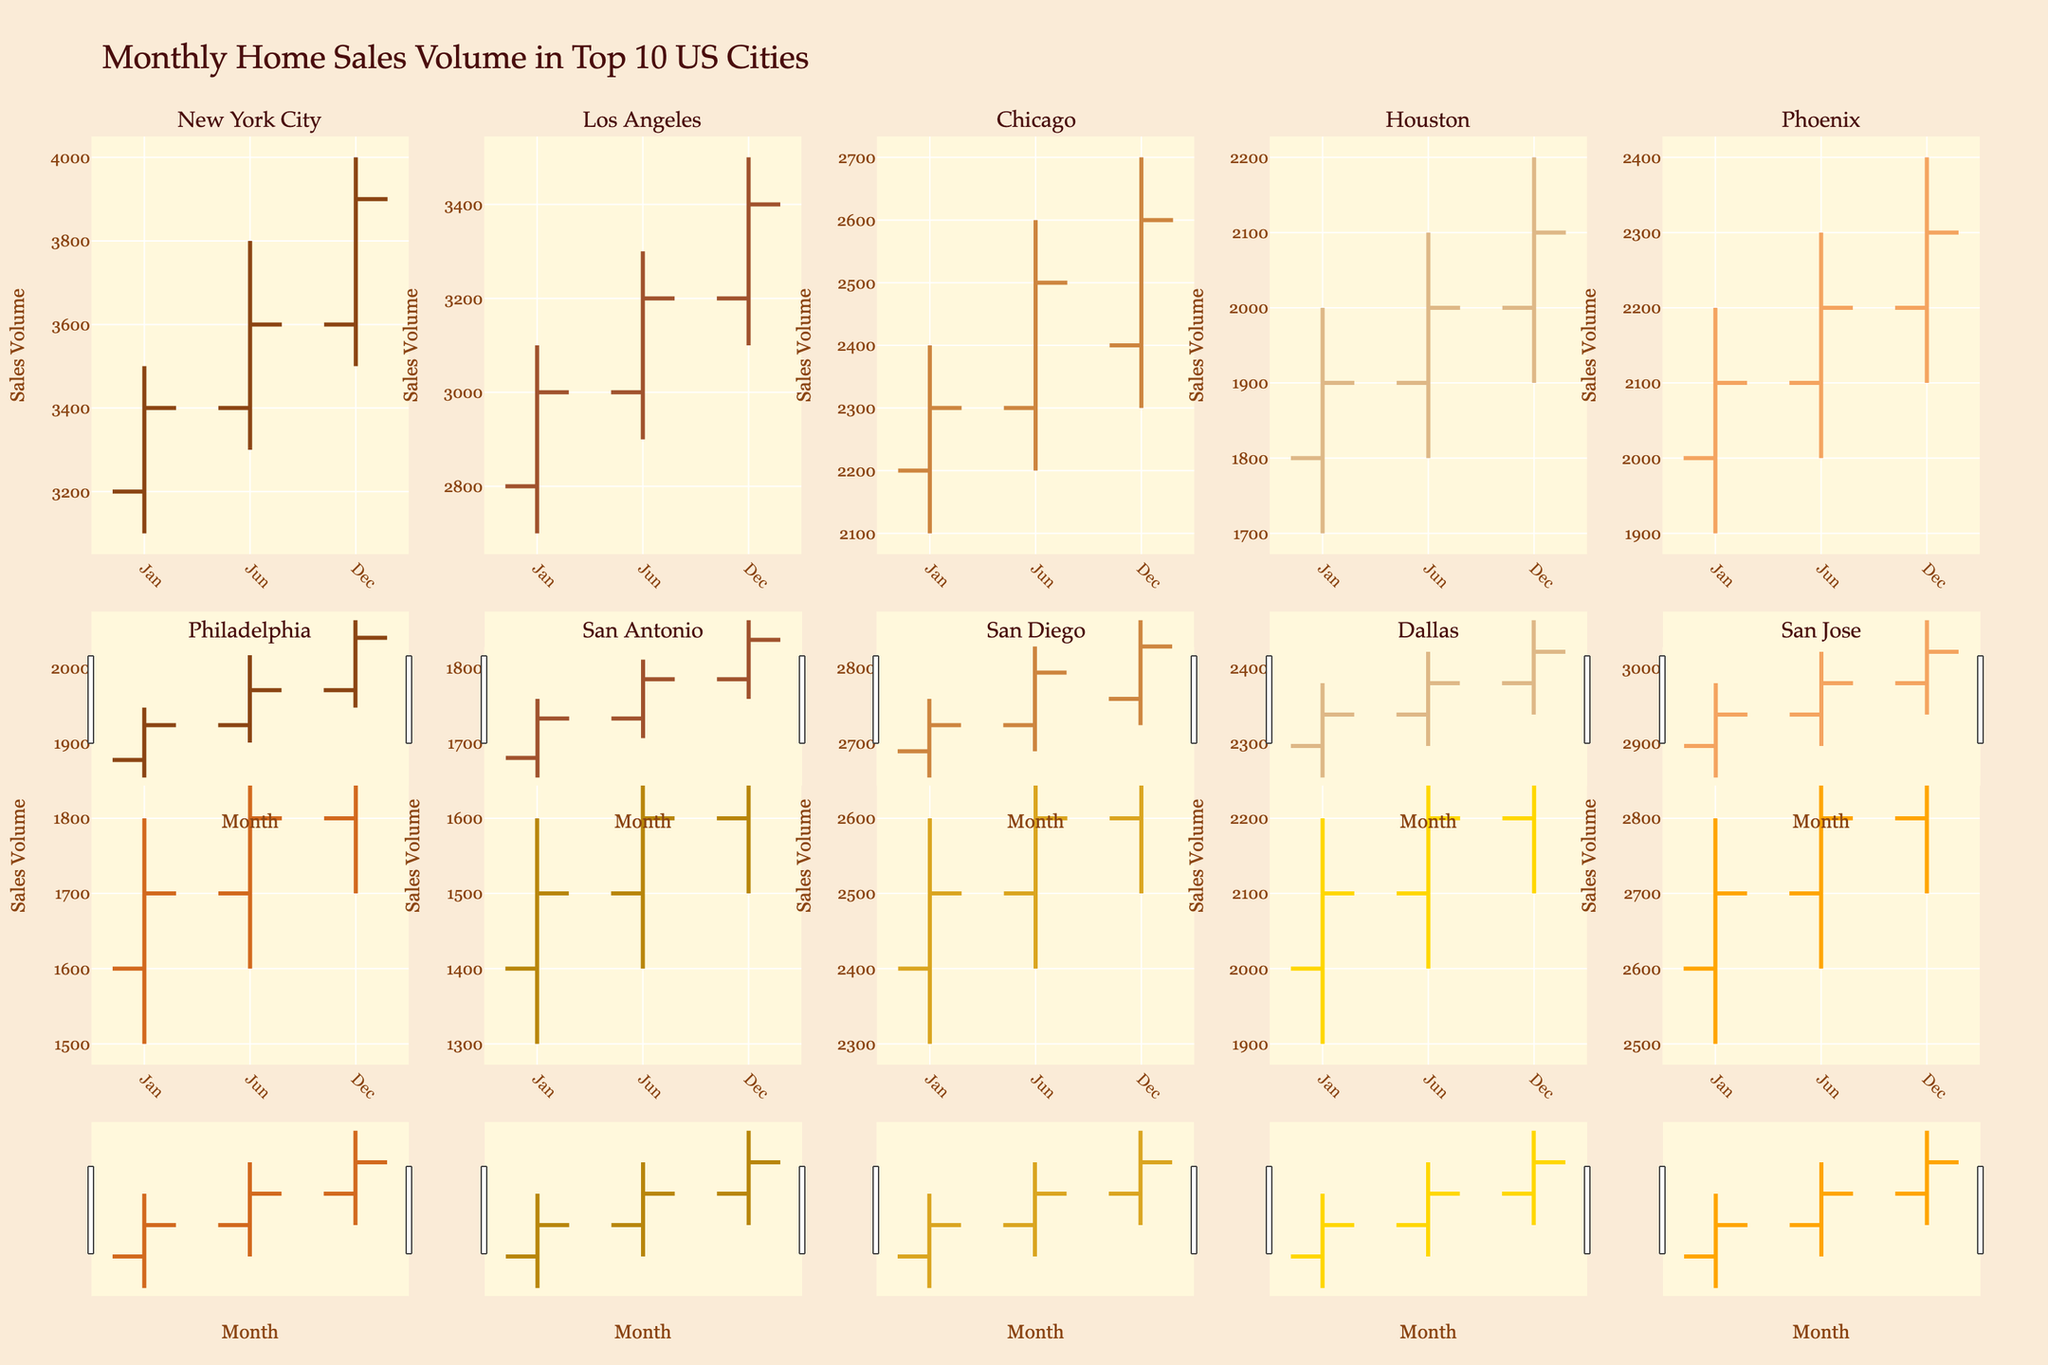What is the main title of the chart? The chart title is located at the top and provides an overview of what the chart represents.
Answer: Monthly Home Sales Volume in Top 10 US Cities Which city had the highest closing sales volume in December? To determine this, locate the OHLC chart for December for each city and compare the closing values. New York City closes at 3900, Los Angeles at 3400, Chicago at 2600, Houston at 2100, Phoenix at 2300, Philadelphia at 1900, San Antonio at 1700, San Diego at 2700, Dallas at 2300, and San Jose at 2900.
Answer: New York City What is the difference in the closing sales volume between January and December for Los Angeles? Find the closing values for Los Angeles in January (3000) and December (3400), then subtract the January value from the December value. 3400 - 3000 = 400
Answer: 400 Which city experienced the highest increase in closing sales volume from January to December? Determine the closing values in January and December for each city and calculate the differences. New York City: 3400 to 3900 (500), Los Angeles: 3000 to 3400 (400), Chicago: 2300 to 2600 (300), Houston: 1900 to 2100 (200), Phoenix: 2100 to 2300 (200), Philadelphia: 1700 to 1900 (200), San Antonio: 1500 to 1700 (200), San Diego: 2500 to 2700 (200), Dallas: 2100 to 2300 (200), San Jose: 2700 to 2900 (200). New York City has the highest increase of 500.
Answer: New York City How many cities have a higher closing sales volume in June compared to January? Compare the January and June closing values for each city. New York City: 3400 vs 3600, Los Angeles: 3000 vs 3200, Chicago: 2300 vs 2500, Houston: 1900 vs 2000, Phoenix: 2100 vs 2200, Philadelphia: 1700 vs 1800, San Antonio: 1500 vs 1600, San Diego: 2500 vs 2600, Dallas: 2100 vs 2200, San Jose: 2700 vs 2800. Each city has a higher closing value in June than in January.
Answer: 10 For Chicago, which month had the highest high sales volume? Look at the High values for Chicago in January (2400), June (2600), and December (2700). December has the highest high sales volume of 2700.
Answer: December Between Houston and Phoenix, which city had a higher average closing sales volume across the year? Calculate the yearly average closing value for Houston (1900+2000+2100)/3 = 2000 and Phoenix (2100+2200+2300)/3 = 2200. Compare these averages. Phoenix has the higher average of 2200.
Answer: Phoenix Which city showed the smallest range (difference between high and low) in any given month? Calculate the range for each city-month and identify the smallest. For instance, New York City in January: 3500-3100=400. The smallest range is Phoenix in January: 2200-1900=300.
Answer: Phoenix in January 